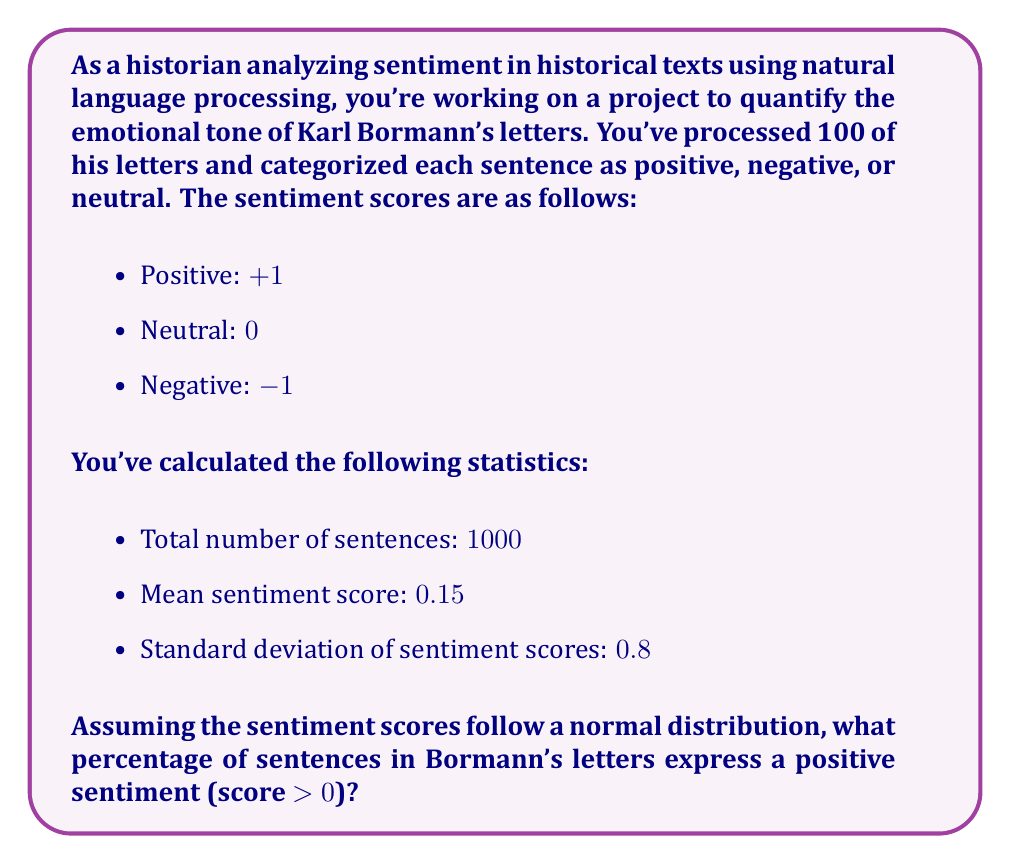Can you solve this math problem? To solve this problem, we'll use the properties of the normal distribution and the z-score formula. Here's a step-by-step approach:

1. Identify the given information:
   - Mean (μ) = 0.15
   - Standard deviation (σ) = 0.8
   - We want to find the percentage of scores greater than 0

2. Calculate the z-score for a sentiment score of 0:
   $$ z = \frac{x - \mu}{\sigma} = \frac{0 - 0.15}{0.8} = -0.1875 $$

3. Use a standard normal distribution table or calculator to find the area to the left of z = -0.1875. This represents the proportion of scores less than or equal to 0.
   Area to the left of z = -0.1875 ≈ 0.4257

4. The area to the right of z = -0.1875 represents the proportion of positive scores (> 0):
   $$ 1 - 0.4257 = 0.5743 $$

5. Convert the proportion to a percentage:
   $$ 0.5743 \times 100\% = 57.43\% $$

Therefore, approximately 57.43% of the sentences in Bormann's letters express a positive sentiment.
Answer: 57.43% 